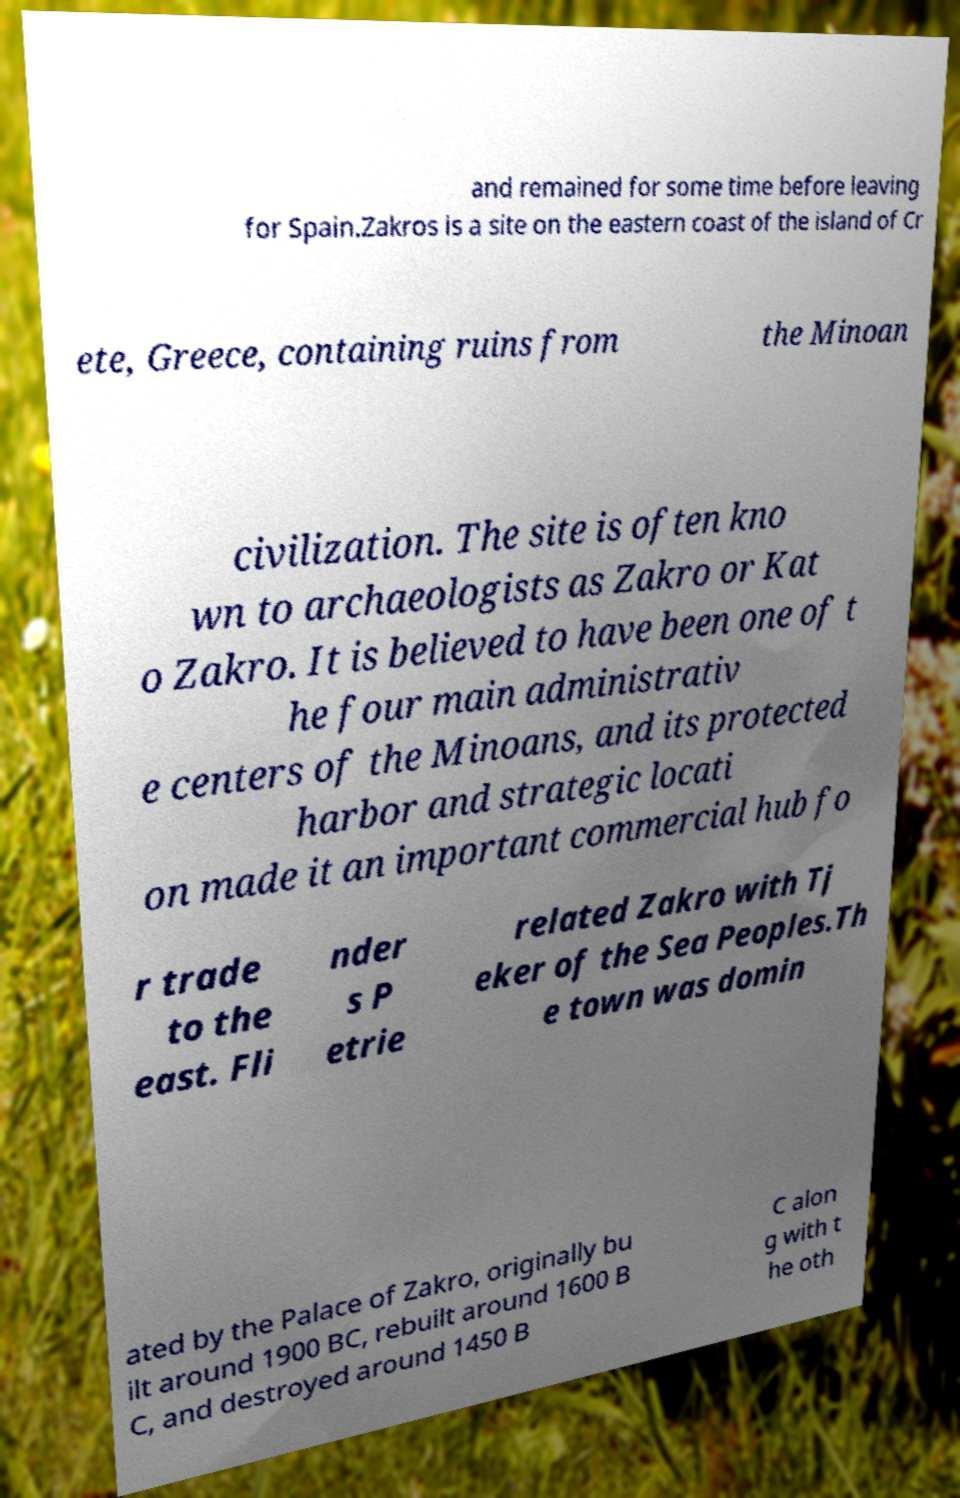Can you accurately transcribe the text from the provided image for me? and remained for some time before leaving for Spain.Zakros is a site on the eastern coast of the island of Cr ete, Greece, containing ruins from the Minoan civilization. The site is often kno wn to archaeologists as Zakro or Kat o Zakro. It is believed to have been one of t he four main administrativ e centers of the Minoans, and its protected harbor and strategic locati on made it an important commercial hub fo r trade to the east. Fli nder s P etrie related Zakro with Tj eker of the Sea Peoples.Th e town was domin ated by the Palace of Zakro, originally bu ilt around 1900 BC, rebuilt around 1600 B C, and destroyed around 1450 B C alon g with t he oth 